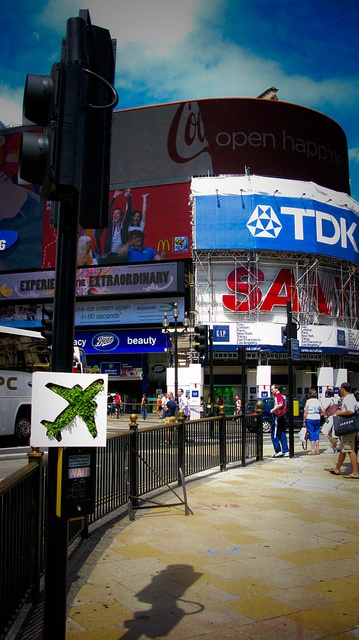Describe the objects in this image and their specific colors. I can see traffic light in darkblue, black, blue, and gray tones, bus in darkblue, black, gray, darkgray, and lightgray tones, people in darkblue, black, maroon, purple, and gray tones, people in darkblue, maroon, darkgray, black, and brown tones, and people in darkblue, black, navy, lightgray, and maroon tones in this image. 